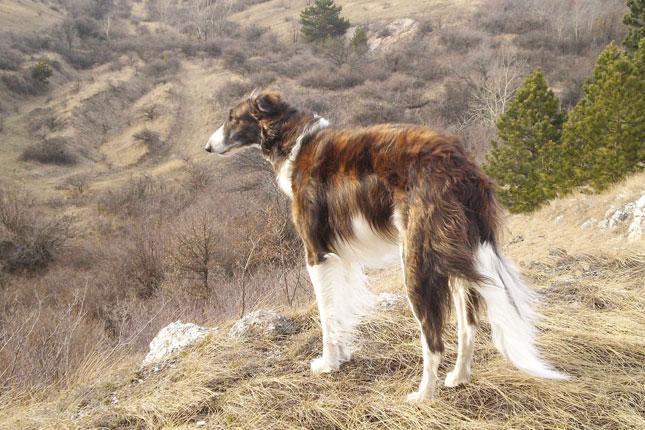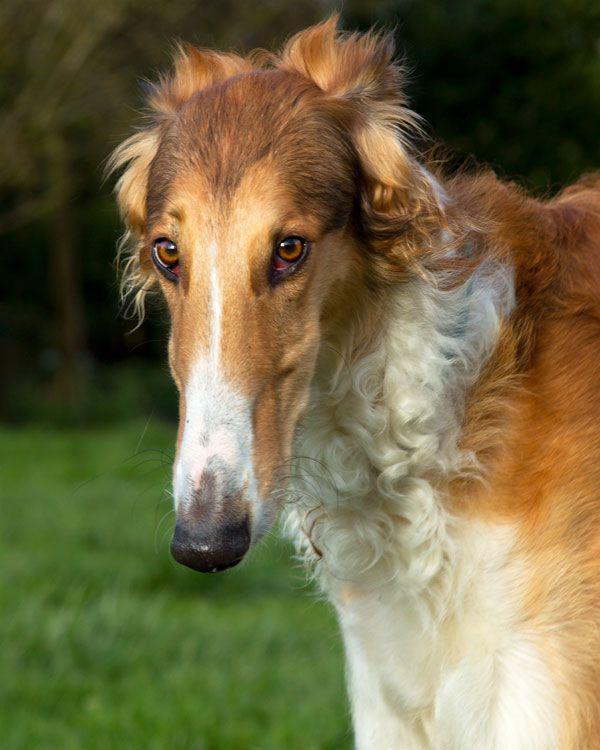The first image is the image on the left, the second image is the image on the right. Assess this claim about the two images: "There are two dogs". Correct or not? Answer yes or no. Yes. 